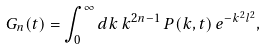<formula> <loc_0><loc_0><loc_500><loc_500>G _ { n } ( t ) = \int _ { 0 } ^ { \infty } d k \, k ^ { 2 n - 1 } \, P ( k , t ) \, e ^ { - k ^ { 2 } l ^ { 2 } } ,</formula> 